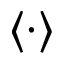<formula> <loc_0><loc_0><loc_500><loc_500>\langle \cdot \rangle</formula> 